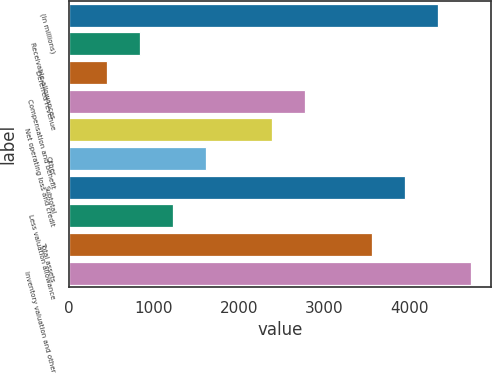<chart> <loc_0><loc_0><loc_500><loc_500><bar_chart><fcel>(In millions)<fcel>Receivable allowances<fcel>Deferred revenue<fcel>Compensation and benefit<fcel>Net operating loss and credit<fcel>Other<fcel>Subtotal<fcel>Less valuation allowance<fcel>Total assets<fcel>Inventory valuation and other<nl><fcel>4335.8<fcel>836.6<fcel>447.8<fcel>2780.6<fcel>2391.8<fcel>1614.2<fcel>3947<fcel>1225.4<fcel>3558.2<fcel>4724.6<nl></chart> 